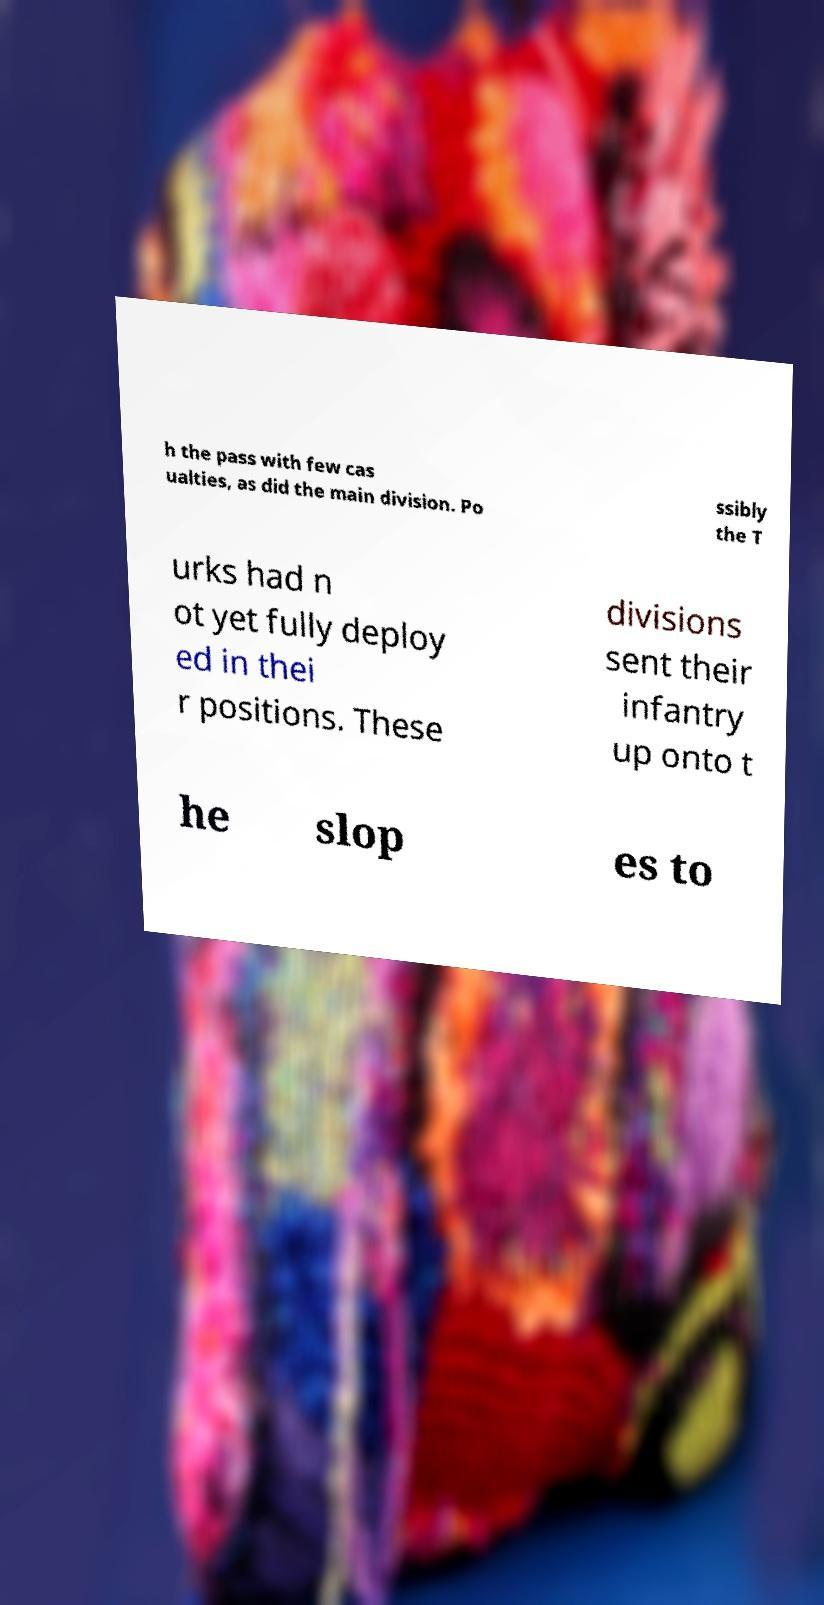Please identify and transcribe the text found in this image. h the pass with few cas ualties, as did the main division. Po ssibly the T urks had n ot yet fully deploy ed in thei r positions. These divisions sent their infantry up onto t he slop es to 